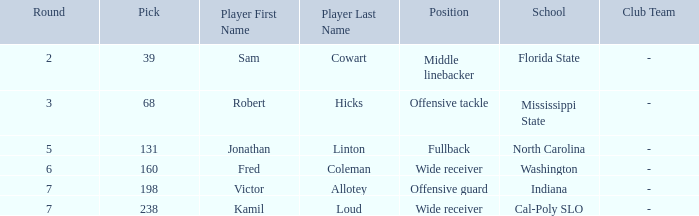Which Round has a School/Club Team of indiana, and a Pick smaller than 198? None. 